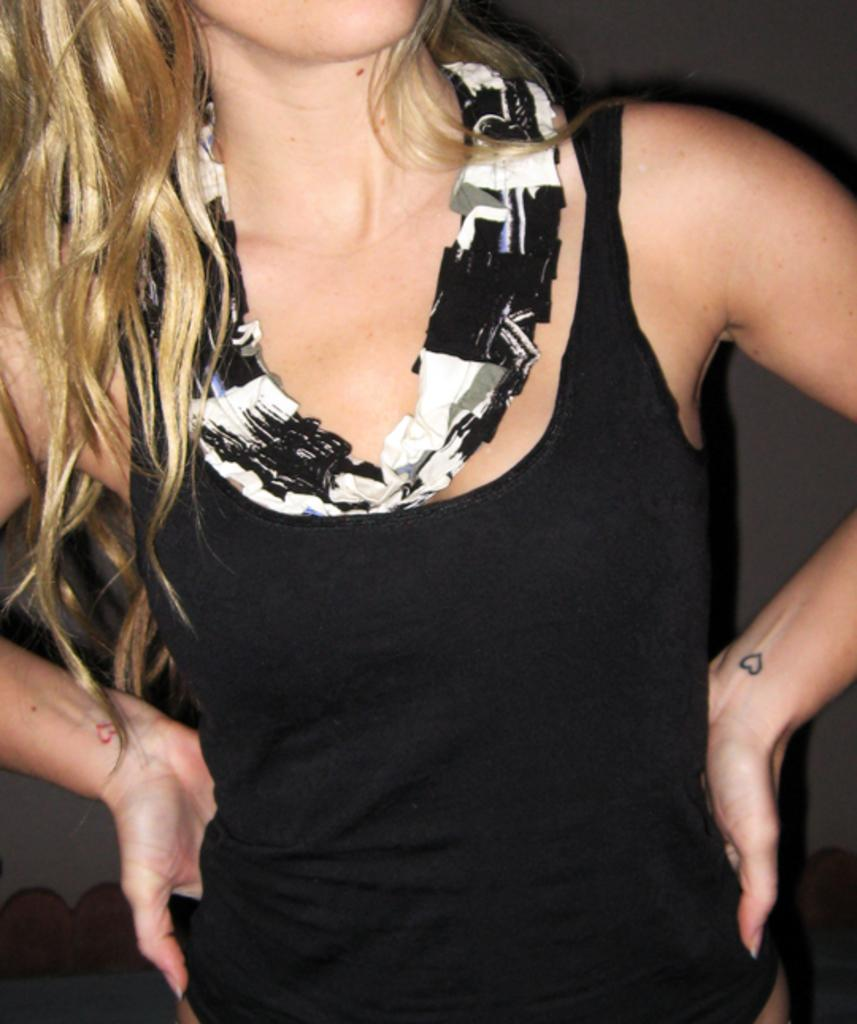Who is the main subject in the image? There is a woman in the image. What is the woman wearing? The woman is wearing a black dress. Can you describe the woman's hair? The woman has golden hair. What is the woman doing with her hands in the image? The woman's hands are placed on her hip. What type of cloth is the woman using to expand her knowledge in the image? There is no cloth or indication of knowledge expansion present in the image. 